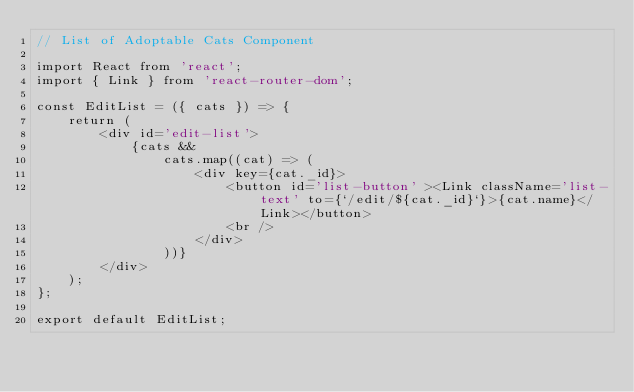<code> <loc_0><loc_0><loc_500><loc_500><_JavaScript_>// List of Adoptable Cats Component

import React from 'react';
import { Link } from 'react-router-dom';

const EditList = ({ cats }) => {
    return (
        <div id='edit-list'>
            {cats &&
                cats.map((cat) => (
                    <div key={cat._id}>
                        <button id='list-button' ><Link className='list-text' to={`/edit/${cat._id}`}>{cat.name}</Link></button>
                        <br />
                    </div>
                ))}
        </div>
    );
};

export default EditList;</code> 